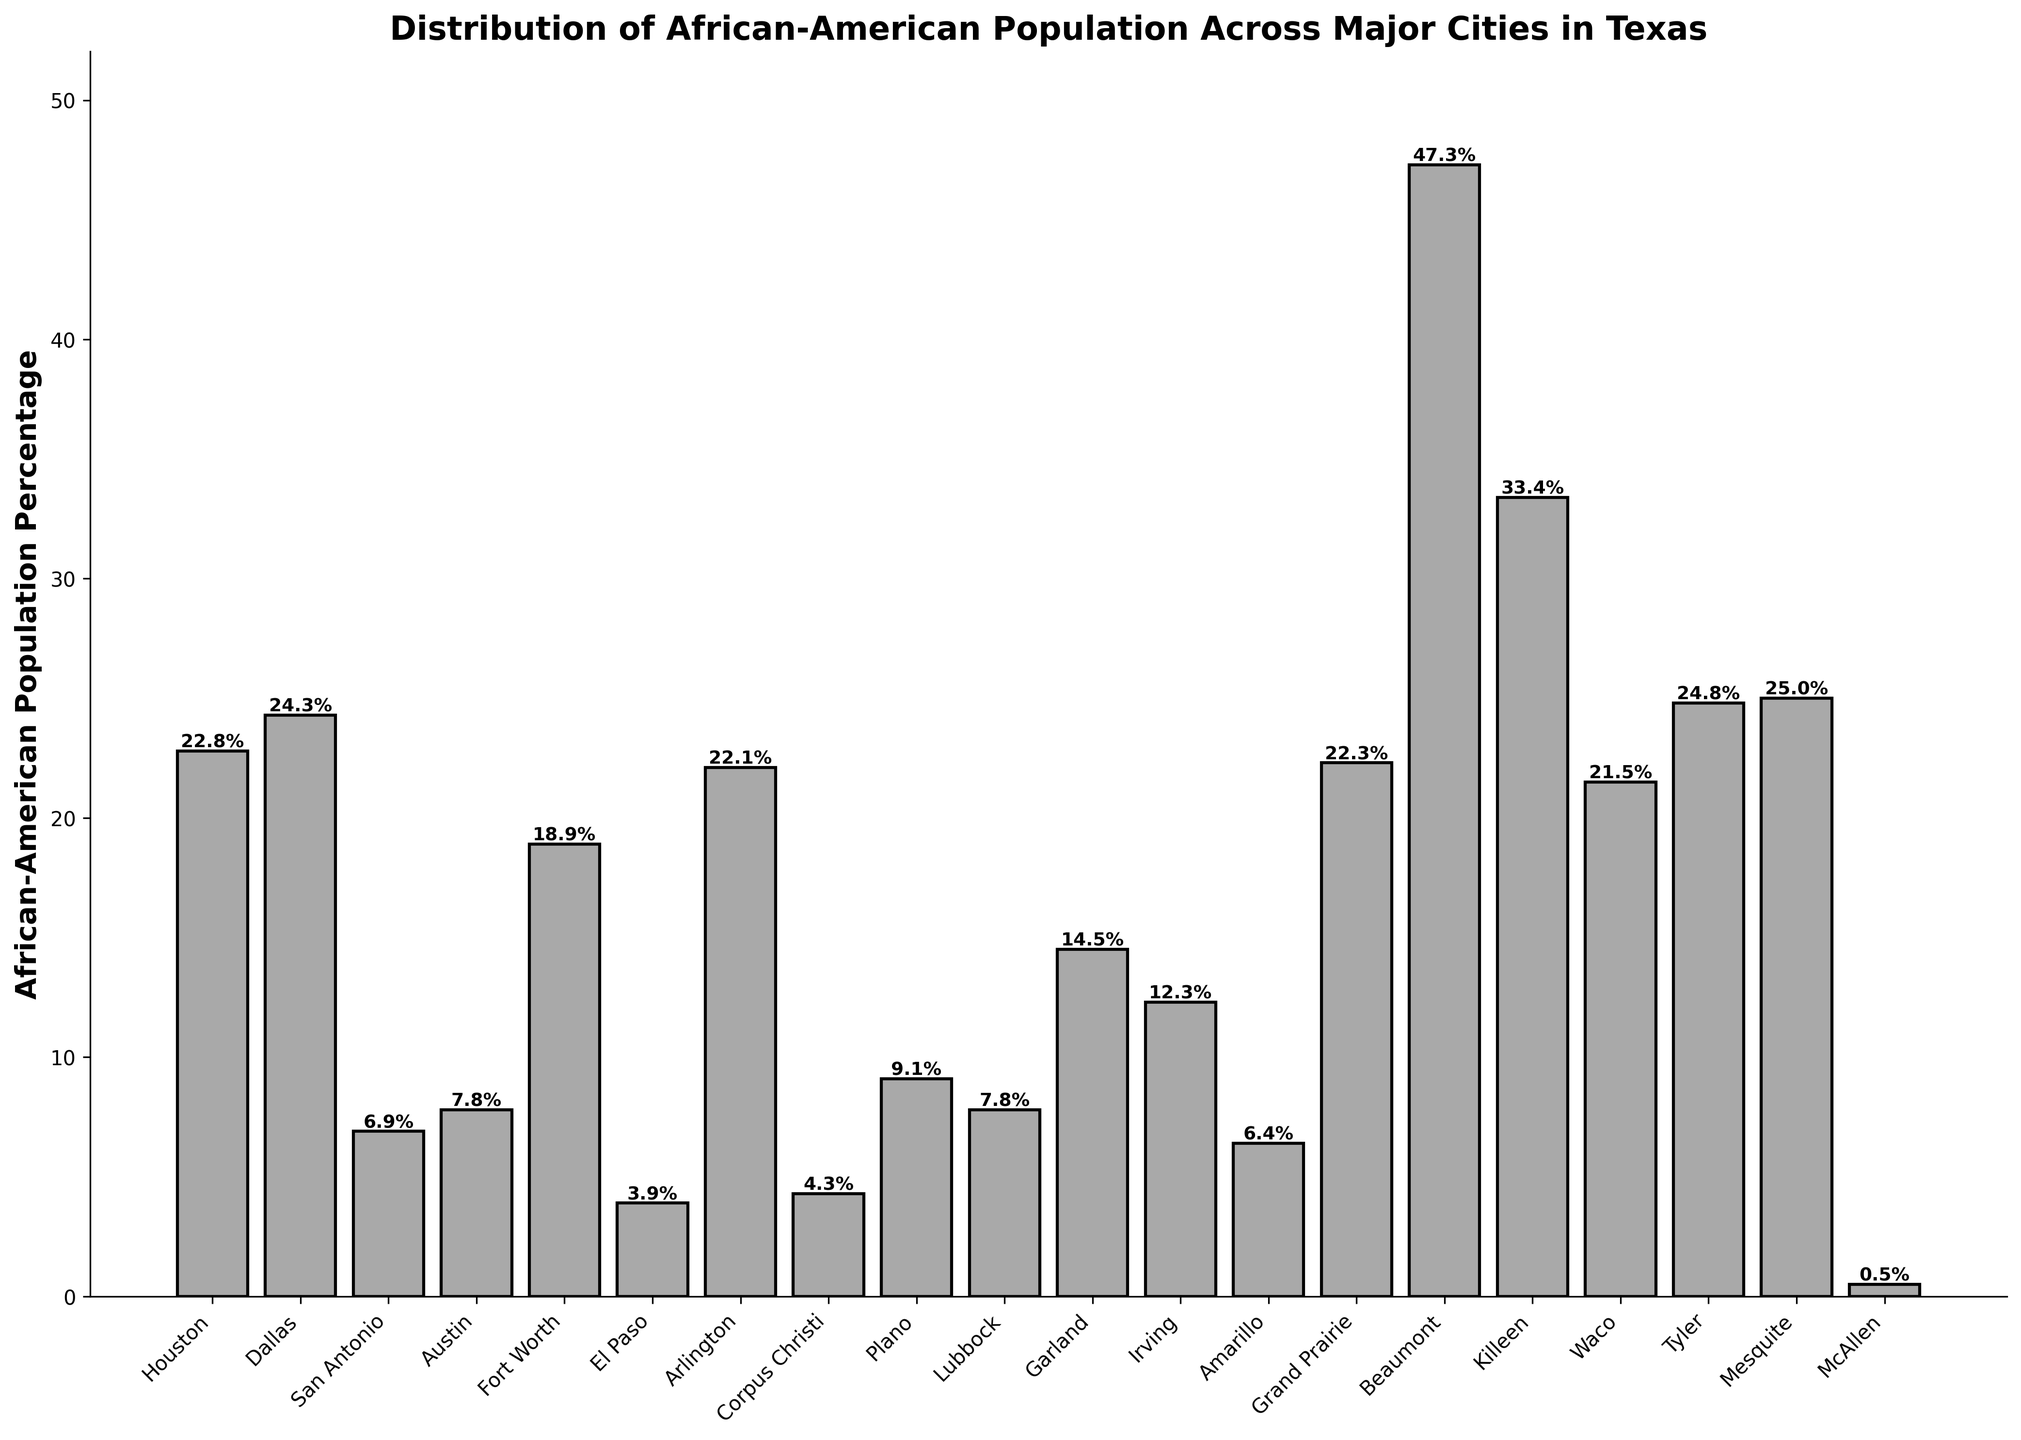Which city has the highest percentage of African-American population? The data shows that Beaumont has the highest bar with an African-American population percentage of 47.3.
Answer: Beaumont What is the difference between the African-American population percentage of Amarillo and Arlington? The percentage for Amarillo is 6.4, and for Arlington, it is 22.1. The difference is 22.1 - 6.4 = 15.7.
Answer: 15.7 Which cities have an African-American population percentage greater than 20%? The bars for Houston (22.8), Dallas (24.3), Fort Worth (18.9), Arlington (22.1), Grand Prairie (22.3), Beaumont (47.3), Killeen (33.4), Waco (21.5), Tyler (24.8), and Mesquite (25.0) are over 20%, except for Fort Worth. So, the cities are Houston, Dallas, Arlington, Grand Prairie, Beaumont, Killeen, Waco, Tyler, and Mesquite.
Answer: Houston, Dallas, Arlington, Grand Prairie, Beaumont, Killeen, Waco, Tyler, Mesquite By how much does the African-American population percentage of Dallas exceed that of San Antonio? The African-American population percentage for Dallas is 24.3, while for San Antonio, it is 6.9. The difference is 24.3 - 6.9 = 17.4.
Answer: 17.4 Calculate the average African-American population percentage of the cities with percentages less than 10%. The percentages for San Antonio (6.9), Austin (7.8), El Paso (3.9), Corpus Christi (4.3), Plano (9.1), Lubbock (7.8), Amarillo (6.4), and McAllen (0.5) sum up to 47.7. These are 8 cities, so the average is 47.7 / 8 = 5.96.
Answer: 5.96 Which city has the lowest percentage of African-American population, and what is that percentage? McAllen has the lowest bar, indicating an African-American population percentage of 0.5.
Answer: McAllen, 0.5 Is the African-American population percentage in Irving higher than in Garland? The percentage for Irving is 12.3, and for Garland, it is 14.5. Therefore, Irving's percentage is not higher than Garland's.
Answer: No Identify the cities where the African-American population percentage falls between 15% and 25%. The cities with percentages in this range are Houston (22.8), Dallas (24.3), Fort Worth (18.9), Grand Prairie (22.3), Waco (21.5), Tyler (24.8), Mesquite (25.0), and Garland (14.5). However, Garland just misses the range. So the cities are Houston, Dallas, Fort Worth, Grand Prairie, Waco, Tyler, and Mesquite.
Answer: Houston, Dallas, Fort Worth, Grand Prairie, Waco, Tyler, Mesquite 